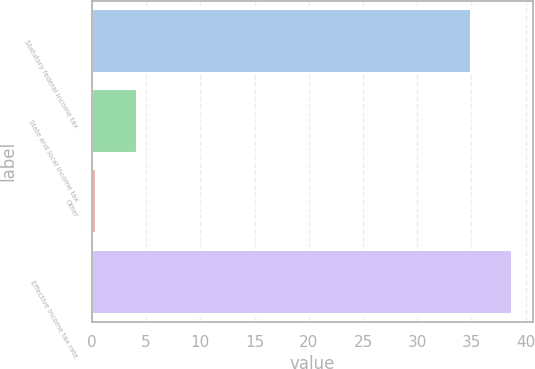Convert chart to OTSL. <chart><loc_0><loc_0><loc_500><loc_500><bar_chart><fcel>Statutory federal income tax<fcel>State and local income tax<fcel>Other<fcel>Effective income tax rate<nl><fcel>35<fcel>4.13<fcel>0.4<fcel>38.73<nl></chart> 